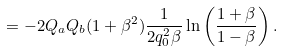<formula> <loc_0><loc_0><loc_500><loc_500>= - 2 Q _ { a } Q _ { b } ( 1 + \beta ^ { 2 } ) { \frac { 1 } { 2 q _ { 0 } ^ { 2 } \beta } } \ln \left ( { \frac { 1 + \beta } { 1 - \beta } } \right ) .</formula> 